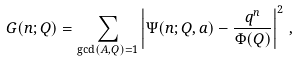Convert formula to latex. <formula><loc_0><loc_0><loc_500><loc_500>G ( n ; Q ) = \sum _ { \gcd ( A , Q ) = 1 } \left | \Psi ( n ; Q , a ) - \frac { q ^ { n } } { \Phi ( Q ) } \right | ^ { 2 } \, ,</formula> 